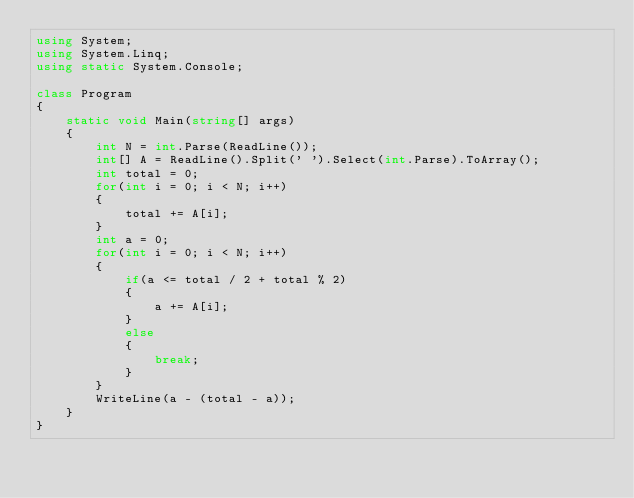<code> <loc_0><loc_0><loc_500><loc_500><_C#_>using System;
using System.Linq;
using static System.Console;

class Program
{
    static void Main(string[] args)
    {
        int N = int.Parse(ReadLine());
        int[] A = ReadLine().Split(' ').Select(int.Parse).ToArray();
        int total = 0;
        for(int i = 0; i < N; i++)
        {
            total += A[i];
        }
        int a = 0;
        for(int i = 0; i < N; i++)
        {
            if(a <= total / 2 + total % 2)
            {
                a += A[i];
            }
            else
            {
                break;
            }
        }
        WriteLine(a - (total - a));
    }
}
</code> 